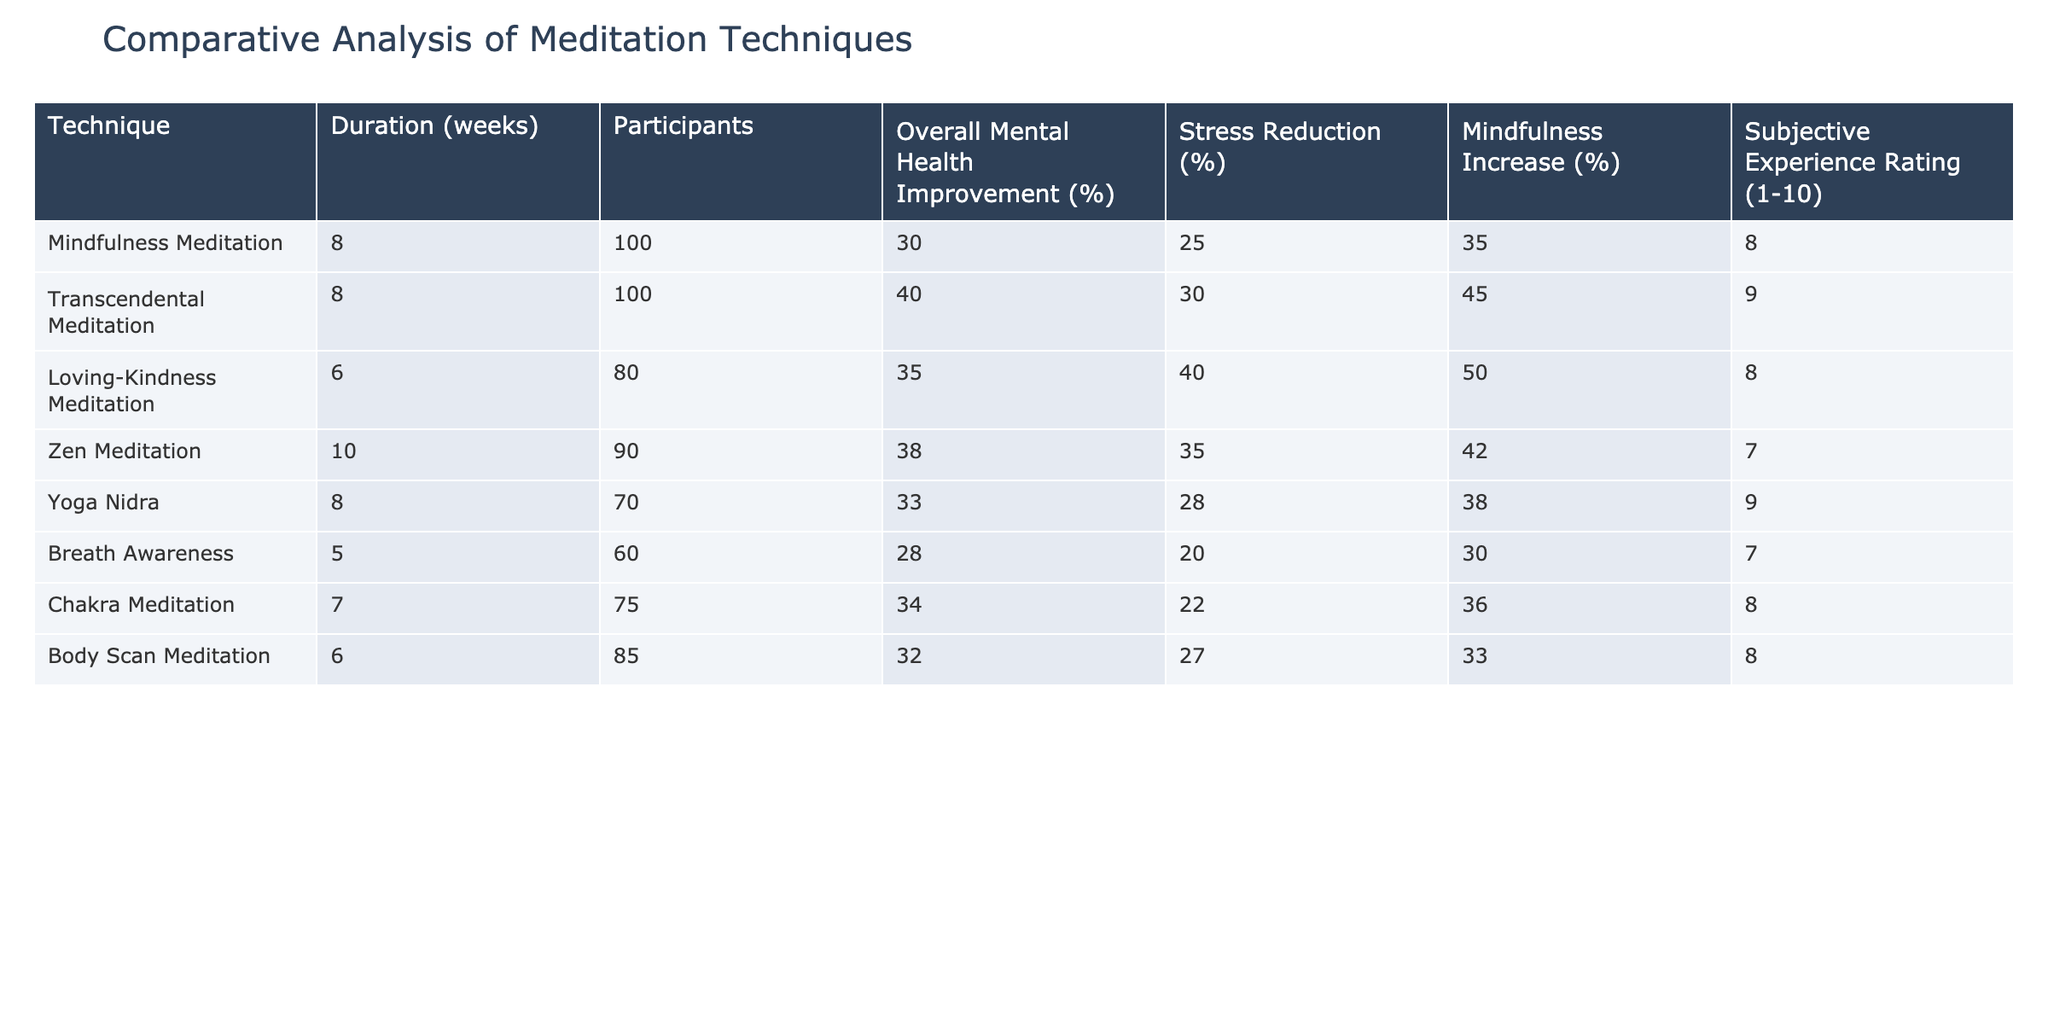What is the overall mental health improvement percentage for Transcendental Meditation? The table shows that the overall mental health improvement percentage for Transcendental Meditation is listed as 40%.
Answer: 40% Which meditation technique had the lowest stress reduction percentage? By examining the stress reduction percentages listed in the table, Breath Awareness has the lowest percentage at 20%.
Answer: 20% What is the average mindfulness increase across all techniques? To find the average mindfulness increase, we sum the mindfulness increase percentages: (35 + 45 + 50 + 42 + 38 + 30 + 36 + 33) = 309. There are 8 techniques, so the average is 309 / 8 = 38.625.
Answer: 38.625 Is the subjective experience rating higher for Loving-Kindness Meditation than for Zen Meditation? The subjective experience rating for Loving-Kindness Meditation is 8, and for Zen Meditation, it is 7. Since 8 is greater than 7, the statement is true.
Answer: Yes Which technique had the highest overall mental health improvement percentage, and what was the percentage? By comparing the overall mental health improvement percentages, Transcendental Meditation has the highest percentage at 40%.
Answer: Transcendental Meditation, 40% How much more does Loving-Kindness Meditation improve overall mental health compared to Breath Awareness? The overall mental health improvement for Loving-Kindness Meditation is 35%, and for Breath Awareness, it is 28%. The difference is 35 - 28 = 7%.
Answer: 7% Which two techniques had a subjective experience rating of 8? From the table, both Mindfulness Meditation and Chakra Meditation have a subjective experience rating of 8.
Answer: Mindfulness Meditation and Chakra Meditation What is the total number of participants across all meditation techniques? Summing the participants from each technique gives: 100 + 100 + 80 + 90 + 70 + 60 + 75 + 85 = 760 participants in total.
Answer: 760 